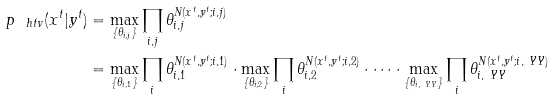Convert formula to latex. <formula><loc_0><loc_0><loc_500><loc_500>p _ { \ h t v } ( x ^ { t } | y ^ { t } ) & = \max _ { \{ \theta _ { i , j } \} } \prod _ { i , j } \theta _ { i , j } ^ { N ( x ^ { t } , y ^ { t } ; i , j ) } \\ & = \max _ { \{ \theta _ { i , 1 } \} } \prod _ { i } \theta _ { i , 1 } ^ { N ( x ^ { t } , y ^ { t } ; i , 1 ) } \cdot \max _ { \{ \theta _ { i , 2 } \} } \prod _ { i } \theta _ { i , 2 } ^ { N ( x ^ { t } , y ^ { t } ; i , 2 ) } \cdot \dots \cdot \max _ { \{ \theta _ { i , \ Y Y } \} } \prod _ { i } \theta _ { i , \ Y Y } ^ { N ( x ^ { t } , y ^ { t } ; i , \ Y Y ) }</formula> 